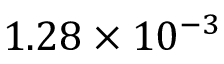<formula> <loc_0><loc_0><loc_500><loc_500>1 . 2 8 \times 1 0 ^ { - 3 }</formula> 